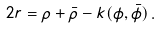<formula> <loc_0><loc_0><loc_500><loc_500>2 r = \rho + { \bar { \rho } } - k ( \phi , { \bar { \phi } } ) \, .</formula> 